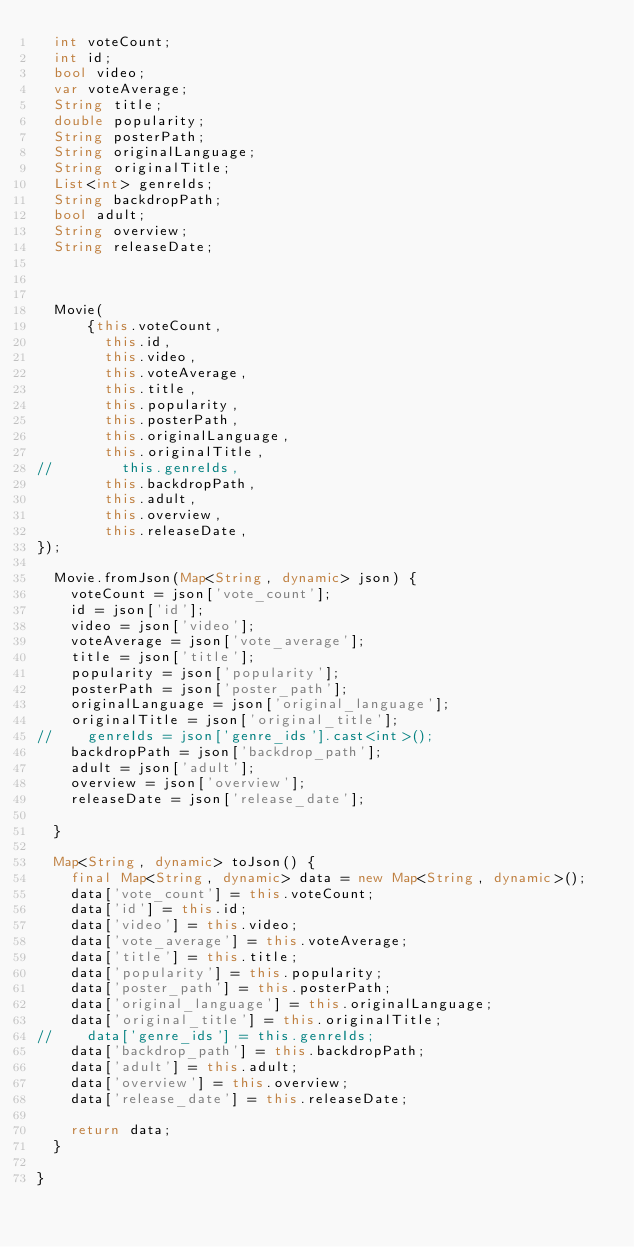Convert code to text. <code><loc_0><loc_0><loc_500><loc_500><_Dart_>  int voteCount;
  int id;
  bool video;
  var voteAverage;
  String title;
  double popularity;
  String posterPath;
  String originalLanguage;
  String originalTitle;
  List<int> genreIds;
  String backdropPath;
  bool adult;
  String overview;
  String releaseDate;



  Movie(
      {this.voteCount,
        this.id,
        this.video,
        this.voteAverage,
        this.title,
        this.popularity,
        this.posterPath,
        this.originalLanguage,
        this.originalTitle,
//        this.genreIds,
        this.backdropPath,
        this.adult,
        this.overview,
        this.releaseDate,
});

  Movie.fromJson(Map<String, dynamic> json) {
    voteCount = json['vote_count'];
    id = json['id'];
    video = json['video'];
    voteAverage = json['vote_average'];
    title = json['title'];
    popularity = json['popularity'];
    posterPath = json['poster_path'];
    originalLanguage = json['original_language'];
    originalTitle = json['original_title'];
//    genreIds = json['genre_ids'].cast<int>();
    backdropPath = json['backdrop_path'];
    adult = json['adult'];
    overview = json['overview'];
    releaseDate = json['release_date'];

  }

  Map<String, dynamic> toJson() {
    final Map<String, dynamic> data = new Map<String, dynamic>();
    data['vote_count'] = this.voteCount;
    data['id'] = this.id;
    data['video'] = this.video;
    data['vote_average'] = this.voteAverage;
    data['title'] = this.title;
    data['popularity'] = this.popularity;
    data['poster_path'] = this.posterPath;
    data['original_language'] = this.originalLanguage;
    data['original_title'] = this.originalTitle;
//    data['genre_ids'] = this.genreIds;
    data['backdrop_path'] = this.backdropPath;
    data['adult'] = this.adult;
    data['overview'] = this.overview;
    data['release_date'] = this.releaseDate;

    return data;
  }

}</code> 